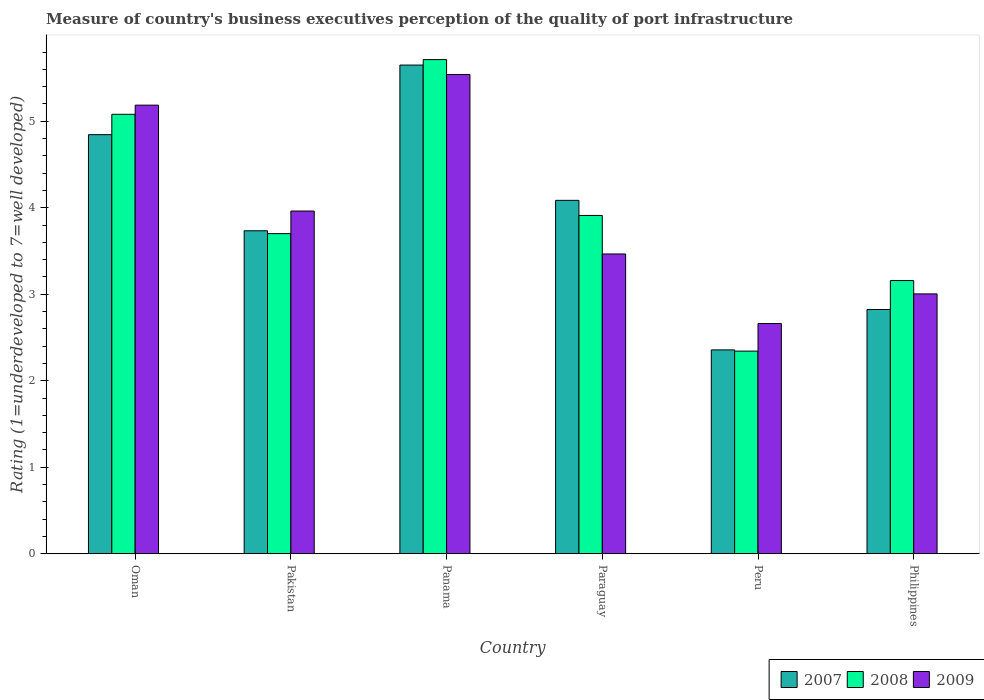How many groups of bars are there?
Ensure brevity in your answer.  6. Are the number of bars per tick equal to the number of legend labels?
Provide a succinct answer. Yes. Are the number of bars on each tick of the X-axis equal?
Provide a short and direct response. Yes. How many bars are there on the 4th tick from the left?
Make the answer very short. 3. How many bars are there on the 1st tick from the right?
Make the answer very short. 3. What is the label of the 1st group of bars from the left?
Offer a terse response. Oman. What is the ratings of the quality of port infrastructure in 2009 in Pakistan?
Give a very brief answer. 3.96. Across all countries, what is the maximum ratings of the quality of port infrastructure in 2007?
Your response must be concise. 5.65. Across all countries, what is the minimum ratings of the quality of port infrastructure in 2007?
Offer a very short reply. 2.36. In which country was the ratings of the quality of port infrastructure in 2009 maximum?
Give a very brief answer. Panama. In which country was the ratings of the quality of port infrastructure in 2009 minimum?
Make the answer very short. Peru. What is the total ratings of the quality of port infrastructure in 2008 in the graph?
Your answer should be compact. 23.91. What is the difference between the ratings of the quality of port infrastructure in 2009 in Oman and that in Pakistan?
Offer a terse response. 1.22. What is the difference between the ratings of the quality of port infrastructure in 2009 in Philippines and the ratings of the quality of port infrastructure in 2007 in Peru?
Give a very brief answer. 0.65. What is the average ratings of the quality of port infrastructure in 2007 per country?
Make the answer very short. 3.92. What is the difference between the ratings of the quality of port infrastructure of/in 2009 and ratings of the quality of port infrastructure of/in 2008 in Paraguay?
Ensure brevity in your answer.  -0.45. What is the ratio of the ratings of the quality of port infrastructure in 2009 in Pakistan to that in Paraguay?
Ensure brevity in your answer.  1.14. Is the ratings of the quality of port infrastructure in 2008 in Panama less than that in Paraguay?
Make the answer very short. No. What is the difference between the highest and the second highest ratings of the quality of port infrastructure in 2009?
Your answer should be very brief. 1.22. What is the difference between the highest and the lowest ratings of the quality of port infrastructure in 2008?
Provide a succinct answer. 3.37. Is the sum of the ratings of the quality of port infrastructure in 2007 in Pakistan and Panama greater than the maximum ratings of the quality of port infrastructure in 2008 across all countries?
Your answer should be compact. Yes. What does the 3rd bar from the right in Paraguay represents?
Make the answer very short. 2007. How many bars are there?
Offer a terse response. 18. How many countries are there in the graph?
Give a very brief answer. 6. What is the difference between two consecutive major ticks on the Y-axis?
Provide a succinct answer. 1. Does the graph contain any zero values?
Offer a terse response. No. Where does the legend appear in the graph?
Your answer should be compact. Bottom right. How many legend labels are there?
Ensure brevity in your answer.  3. How are the legend labels stacked?
Give a very brief answer. Horizontal. What is the title of the graph?
Provide a succinct answer. Measure of country's business executives perception of the quality of port infrastructure. What is the label or title of the Y-axis?
Ensure brevity in your answer.  Rating (1=underdeveloped to 7=well developed). What is the Rating (1=underdeveloped to 7=well developed) of 2007 in Oman?
Ensure brevity in your answer.  4.85. What is the Rating (1=underdeveloped to 7=well developed) in 2008 in Oman?
Make the answer very short. 5.08. What is the Rating (1=underdeveloped to 7=well developed) in 2009 in Oman?
Provide a succinct answer. 5.19. What is the Rating (1=underdeveloped to 7=well developed) of 2007 in Pakistan?
Offer a terse response. 3.73. What is the Rating (1=underdeveloped to 7=well developed) in 2008 in Pakistan?
Ensure brevity in your answer.  3.7. What is the Rating (1=underdeveloped to 7=well developed) in 2009 in Pakistan?
Keep it short and to the point. 3.96. What is the Rating (1=underdeveloped to 7=well developed) of 2007 in Panama?
Your response must be concise. 5.65. What is the Rating (1=underdeveloped to 7=well developed) in 2008 in Panama?
Your response must be concise. 5.71. What is the Rating (1=underdeveloped to 7=well developed) in 2009 in Panama?
Your answer should be compact. 5.54. What is the Rating (1=underdeveloped to 7=well developed) in 2007 in Paraguay?
Your answer should be very brief. 4.09. What is the Rating (1=underdeveloped to 7=well developed) in 2008 in Paraguay?
Give a very brief answer. 3.91. What is the Rating (1=underdeveloped to 7=well developed) in 2009 in Paraguay?
Provide a short and direct response. 3.47. What is the Rating (1=underdeveloped to 7=well developed) in 2007 in Peru?
Provide a short and direct response. 2.36. What is the Rating (1=underdeveloped to 7=well developed) in 2008 in Peru?
Your answer should be compact. 2.34. What is the Rating (1=underdeveloped to 7=well developed) of 2009 in Peru?
Keep it short and to the point. 2.66. What is the Rating (1=underdeveloped to 7=well developed) in 2007 in Philippines?
Your answer should be compact. 2.82. What is the Rating (1=underdeveloped to 7=well developed) in 2008 in Philippines?
Make the answer very short. 3.16. What is the Rating (1=underdeveloped to 7=well developed) of 2009 in Philippines?
Ensure brevity in your answer.  3. Across all countries, what is the maximum Rating (1=underdeveloped to 7=well developed) of 2007?
Offer a terse response. 5.65. Across all countries, what is the maximum Rating (1=underdeveloped to 7=well developed) of 2008?
Offer a terse response. 5.71. Across all countries, what is the maximum Rating (1=underdeveloped to 7=well developed) of 2009?
Your answer should be very brief. 5.54. Across all countries, what is the minimum Rating (1=underdeveloped to 7=well developed) of 2007?
Your answer should be very brief. 2.36. Across all countries, what is the minimum Rating (1=underdeveloped to 7=well developed) of 2008?
Give a very brief answer. 2.34. Across all countries, what is the minimum Rating (1=underdeveloped to 7=well developed) of 2009?
Offer a terse response. 2.66. What is the total Rating (1=underdeveloped to 7=well developed) in 2007 in the graph?
Ensure brevity in your answer.  23.49. What is the total Rating (1=underdeveloped to 7=well developed) of 2008 in the graph?
Keep it short and to the point. 23.91. What is the total Rating (1=underdeveloped to 7=well developed) of 2009 in the graph?
Provide a short and direct response. 23.82. What is the difference between the Rating (1=underdeveloped to 7=well developed) of 2007 in Oman and that in Pakistan?
Your answer should be compact. 1.11. What is the difference between the Rating (1=underdeveloped to 7=well developed) of 2008 in Oman and that in Pakistan?
Give a very brief answer. 1.38. What is the difference between the Rating (1=underdeveloped to 7=well developed) in 2009 in Oman and that in Pakistan?
Ensure brevity in your answer.  1.22. What is the difference between the Rating (1=underdeveloped to 7=well developed) of 2007 in Oman and that in Panama?
Make the answer very short. -0.8. What is the difference between the Rating (1=underdeveloped to 7=well developed) in 2008 in Oman and that in Panama?
Make the answer very short. -0.63. What is the difference between the Rating (1=underdeveloped to 7=well developed) of 2009 in Oman and that in Panama?
Give a very brief answer. -0.35. What is the difference between the Rating (1=underdeveloped to 7=well developed) in 2007 in Oman and that in Paraguay?
Offer a very short reply. 0.76. What is the difference between the Rating (1=underdeveloped to 7=well developed) of 2008 in Oman and that in Paraguay?
Give a very brief answer. 1.17. What is the difference between the Rating (1=underdeveloped to 7=well developed) of 2009 in Oman and that in Paraguay?
Offer a terse response. 1.72. What is the difference between the Rating (1=underdeveloped to 7=well developed) in 2007 in Oman and that in Peru?
Your answer should be compact. 2.49. What is the difference between the Rating (1=underdeveloped to 7=well developed) in 2008 in Oman and that in Peru?
Your response must be concise. 2.74. What is the difference between the Rating (1=underdeveloped to 7=well developed) in 2009 in Oman and that in Peru?
Make the answer very short. 2.53. What is the difference between the Rating (1=underdeveloped to 7=well developed) of 2007 in Oman and that in Philippines?
Provide a succinct answer. 2.02. What is the difference between the Rating (1=underdeveloped to 7=well developed) in 2008 in Oman and that in Philippines?
Make the answer very short. 1.92. What is the difference between the Rating (1=underdeveloped to 7=well developed) of 2009 in Oman and that in Philippines?
Provide a short and direct response. 2.18. What is the difference between the Rating (1=underdeveloped to 7=well developed) of 2007 in Pakistan and that in Panama?
Your response must be concise. -1.92. What is the difference between the Rating (1=underdeveloped to 7=well developed) in 2008 in Pakistan and that in Panama?
Ensure brevity in your answer.  -2.01. What is the difference between the Rating (1=underdeveloped to 7=well developed) in 2009 in Pakistan and that in Panama?
Provide a succinct answer. -1.58. What is the difference between the Rating (1=underdeveloped to 7=well developed) of 2007 in Pakistan and that in Paraguay?
Offer a terse response. -0.35. What is the difference between the Rating (1=underdeveloped to 7=well developed) of 2008 in Pakistan and that in Paraguay?
Your answer should be compact. -0.21. What is the difference between the Rating (1=underdeveloped to 7=well developed) of 2009 in Pakistan and that in Paraguay?
Your answer should be very brief. 0.5. What is the difference between the Rating (1=underdeveloped to 7=well developed) in 2007 in Pakistan and that in Peru?
Keep it short and to the point. 1.38. What is the difference between the Rating (1=underdeveloped to 7=well developed) of 2008 in Pakistan and that in Peru?
Offer a terse response. 1.36. What is the difference between the Rating (1=underdeveloped to 7=well developed) of 2009 in Pakistan and that in Peru?
Provide a succinct answer. 1.3. What is the difference between the Rating (1=underdeveloped to 7=well developed) in 2007 in Pakistan and that in Philippines?
Offer a very short reply. 0.91. What is the difference between the Rating (1=underdeveloped to 7=well developed) in 2008 in Pakistan and that in Philippines?
Offer a terse response. 0.54. What is the difference between the Rating (1=underdeveloped to 7=well developed) in 2009 in Pakistan and that in Philippines?
Your answer should be compact. 0.96. What is the difference between the Rating (1=underdeveloped to 7=well developed) of 2007 in Panama and that in Paraguay?
Offer a very short reply. 1.56. What is the difference between the Rating (1=underdeveloped to 7=well developed) in 2008 in Panama and that in Paraguay?
Give a very brief answer. 1.8. What is the difference between the Rating (1=underdeveloped to 7=well developed) of 2009 in Panama and that in Paraguay?
Make the answer very short. 2.08. What is the difference between the Rating (1=underdeveloped to 7=well developed) in 2007 in Panama and that in Peru?
Offer a terse response. 3.29. What is the difference between the Rating (1=underdeveloped to 7=well developed) of 2008 in Panama and that in Peru?
Your response must be concise. 3.37. What is the difference between the Rating (1=underdeveloped to 7=well developed) in 2009 in Panama and that in Peru?
Give a very brief answer. 2.88. What is the difference between the Rating (1=underdeveloped to 7=well developed) in 2007 in Panama and that in Philippines?
Offer a terse response. 2.83. What is the difference between the Rating (1=underdeveloped to 7=well developed) of 2008 in Panama and that in Philippines?
Make the answer very short. 2.56. What is the difference between the Rating (1=underdeveloped to 7=well developed) of 2009 in Panama and that in Philippines?
Offer a very short reply. 2.54. What is the difference between the Rating (1=underdeveloped to 7=well developed) in 2007 in Paraguay and that in Peru?
Make the answer very short. 1.73. What is the difference between the Rating (1=underdeveloped to 7=well developed) in 2008 in Paraguay and that in Peru?
Give a very brief answer. 1.57. What is the difference between the Rating (1=underdeveloped to 7=well developed) of 2009 in Paraguay and that in Peru?
Provide a short and direct response. 0.8. What is the difference between the Rating (1=underdeveloped to 7=well developed) in 2007 in Paraguay and that in Philippines?
Your response must be concise. 1.26. What is the difference between the Rating (1=underdeveloped to 7=well developed) of 2008 in Paraguay and that in Philippines?
Provide a succinct answer. 0.75. What is the difference between the Rating (1=underdeveloped to 7=well developed) in 2009 in Paraguay and that in Philippines?
Your response must be concise. 0.46. What is the difference between the Rating (1=underdeveloped to 7=well developed) of 2007 in Peru and that in Philippines?
Offer a very short reply. -0.47. What is the difference between the Rating (1=underdeveloped to 7=well developed) in 2008 in Peru and that in Philippines?
Offer a very short reply. -0.82. What is the difference between the Rating (1=underdeveloped to 7=well developed) of 2009 in Peru and that in Philippines?
Keep it short and to the point. -0.34. What is the difference between the Rating (1=underdeveloped to 7=well developed) of 2007 in Oman and the Rating (1=underdeveloped to 7=well developed) of 2008 in Pakistan?
Your answer should be very brief. 1.14. What is the difference between the Rating (1=underdeveloped to 7=well developed) of 2007 in Oman and the Rating (1=underdeveloped to 7=well developed) of 2009 in Pakistan?
Offer a very short reply. 0.88. What is the difference between the Rating (1=underdeveloped to 7=well developed) in 2008 in Oman and the Rating (1=underdeveloped to 7=well developed) in 2009 in Pakistan?
Offer a terse response. 1.12. What is the difference between the Rating (1=underdeveloped to 7=well developed) of 2007 in Oman and the Rating (1=underdeveloped to 7=well developed) of 2008 in Panama?
Your response must be concise. -0.87. What is the difference between the Rating (1=underdeveloped to 7=well developed) in 2007 in Oman and the Rating (1=underdeveloped to 7=well developed) in 2009 in Panama?
Your answer should be compact. -0.7. What is the difference between the Rating (1=underdeveloped to 7=well developed) of 2008 in Oman and the Rating (1=underdeveloped to 7=well developed) of 2009 in Panama?
Keep it short and to the point. -0.46. What is the difference between the Rating (1=underdeveloped to 7=well developed) in 2007 in Oman and the Rating (1=underdeveloped to 7=well developed) in 2008 in Paraguay?
Your answer should be compact. 0.93. What is the difference between the Rating (1=underdeveloped to 7=well developed) in 2007 in Oman and the Rating (1=underdeveloped to 7=well developed) in 2009 in Paraguay?
Your response must be concise. 1.38. What is the difference between the Rating (1=underdeveloped to 7=well developed) in 2008 in Oman and the Rating (1=underdeveloped to 7=well developed) in 2009 in Paraguay?
Provide a short and direct response. 1.62. What is the difference between the Rating (1=underdeveloped to 7=well developed) in 2007 in Oman and the Rating (1=underdeveloped to 7=well developed) in 2008 in Peru?
Ensure brevity in your answer.  2.5. What is the difference between the Rating (1=underdeveloped to 7=well developed) in 2007 in Oman and the Rating (1=underdeveloped to 7=well developed) in 2009 in Peru?
Provide a succinct answer. 2.18. What is the difference between the Rating (1=underdeveloped to 7=well developed) of 2008 in Oman and the Rating (1=underdeveloped to 7=well developed) of 2009 in Peru?
Make the answer very short. 2.42. What is the difference between the Rating (1=underdeveloped to 7=well developed) of 2007 in Oman and the Rating (1=underdeveloped to 7=well developed) of 2008 in Philippines?
Your response must be concise. 1.69. What is the difference between the Rating (1=underdeveloped to 7=well developed) of 2007 in Oman and the Rating (1=underdeveloped to 7=well developed) of 2009 in Philippines?
Give a very brief answer. 1.84. What is the difference between the Rating (1=underdeveloped to 7=well developed) of 2008 in Oman and the Rating (1=underdeveloped to 7=well developed) of 2009 in Philippines?
Ensure brevity in your answer.  2.08. What is the difference between the Rating (1=underdeveloped to 7=well developed) in 2007 in Pakistan and the Rating (1=underdeveloped to 7=well developed) in 2008 in Panama?
Provide a short and direct response. -1.98. What is the difference between the Rating (1=underdeveloped to 7=well developed) of 2007 in Pakistan and the Rating (1=underdeveloped to 7=well developed) of 2009 in Panama?
Provide a succinct answer. -1.81. What is the difference between the Rating (1=underdeveloped to 7=well developed) in 2008 in Pakistan and the Rating (1=underdeveloped to 7=well developed) in 2009 in Panama?
Make the answer very short. -1.84. What is the difference between the Rating (1=underdeveloped to 7=well developed) in 2007 in Pakistan and the Rating (1=underdeveloped to 7=well developed) in 2008 in Paraguay?
Provide a succinct answer. -0.18. What is the difference between the Rating (1=underdeveloped to 7=well developed) in 2007 in Pakistan and the Rating (1=underdeveloped to 7=well developed) in 2009 in Paraguay?
Make the answer very short. 0.27. What is the difference between the Rating (1=underdeveloped to 7=well developed) in 2008 in Pakistan and the Rating (1=underdeveloped to 7=well developed) in 2009 in Paraguay?
Provide a succinct answer. 0.24. What is the difference between the Rating (1=underdeveloped to 7=well developed) of 2007 in Pakistan and the Rating (1=underdeveloped to 7=well developed) of 2008 in Peru?
Your answer should be very brief. 1.39. What is the difference between the Rating (1=underdeveloped to 7=well developed) of 2007 in Pakistan and the Rating (1=underdeveloped to 7=well developed) of 2009 in Peru?
Provide a short and direct response. 1.07. What is the difference between the Rating (1=underdeveloped to 7=well developed) of 2008 in Pakistan and the Rating (1=underdeveloped to 7=well developed) of 2009 in Peru?
Your response must be concise. 1.04. What is the difference between the Rating (1=underdeveloped to 7=well developed) in 2007 in Pakistan and the Rating (1=underdeveloped to 7=well developed) in 2008 in Philippines?
Offer a very short reply. 0.58. What is the difference between the Rating (1=underdeveloped to 7=well developed) of 2007 in Pakistan and the Rating (1=underdeveloped to 7=well developed) of 2009 in Philippines?
Your response must be concise. 0.73. What is the difference between the Rating (1=underdeveloped to 7=well developed) in 2008 in Pakistan and the Rating (1=underdeveloped to 7=well developed) in 2009 in Philippines?
Your response must be concise. 0.7. What is the difference between the Rating (1=underdeveloped to 7=well developed) of 2007 in Panama and the Rating (1=underdeveloped to 7=well developed) of 2008 in Paraguay?
Your answer should be compact. 1.74. What is the difference between the Rating (1=underdeveloped to 7=well developed) in 2007 in Panama and the Rating (1=underdeveloped to 7=well developed) in 2009 in Paraguay?
Give a very brief answer. 2.18. What is the difference between the Rating (1=underdeveloped to 7=well developed) in 2008 in Panama and the Rating (1=underdeveloped to 7=well developed) in 2009 in Paraguay?
Your response must be concise. 2.25. What is the difference between the Rating (1=underdeveloped to 7=well developed) of 2007 in Panama and the Rating (1=underdeveloped to 7=well developed) of 2008 in Peru?
Your response must be concise. 3.31. What is the difference between the Rating (1=underdeveloped to 7=well developed) in 2007 in Panama and the Rating (1=underdeveloped to 7=well developed) in 2009 in Peru?
Give a very brief answer. 2.99. What is the difference between the Rating (1=underdeveloped to 7=well developed) of 2008 in Panama and the Rating (1=underdeveloped to 7=well developed) of 2009 in Peru?
Your answer should be compact. 3.05. What is the difference between the Rating (1=underdeveloped to 7=well developed) of 2007 in Panama and the Rating (1=underdeveloped to 7=well developed) of 2008 in Philippines?
Provide a succinct answer. 2.49. What is the difference between the Rating (1=underdeveloped to 7=well developed) of 2007 in Panama and the Rating (1=underdeveloped to 7=well developed) of 2009 in Philippines?
Keep it short and to the point. 2.65. What is the difference between the Rating (1=underdeveloped to 7=well developed) in 2008 in Panama and the Rating (1=underdeveloped to 7=well developed) in 2009 in Philippines?
Your response must be concise. 2.71. What is the difference between the Rating (1=underdeveloped to 7=well developed) of 2007 in Paraguay and the Rating (1=underdeveloped to 7=well developed) of 2008 in Peru?
Your answer should be compact. 1.74. What is the difference between the Rating (1=underdeveloped to 7=well developed) in 2007 in Paraguay and the Rating (1=underdeveloped to 7=well developed) in 2009 in Peru?
Offer a terse response. 1.42. What is the difference between the Rating (1=underdeveloped to 7=well developed) in 2008 in Paraguay and the Rating (1=underdeveloped to 7=well developed) in 2009 in Peru?
Ensure brevity in your answer.  1.25. What is the difference between the Rating (1=underdeveloped to 7=well developed) of 2007 in Paraguay and the Rating (1=underdeveloped to 7=well developed) of 2008 in Philippines?
Give a very brief answer. 0.93. What is the difference between the Rating (1=underdeveloped to 7=well developed) in 2007 in Paraguay and the Rating (1=underdeveloped to 7=well developed) in 2009 in Philippines?
Keep it short and to the point. 1.08. What is the difference between the Rating (1=underdeveloped to 7=well developed) in 2008 in Paraguay and the Rating (1=underdeveloped to 7=well developed) in 2009 in Philippines?
Ensure brevity in your answer.  0.91. What is the difference between the Rating (1=underdeveloped to 7=well developed) of 2007 in Peru and the Rating (1=underdeveloped to 7=well developed) of 2008 in Philippines?
Make the answer very short. -0.8. What is the difference between the Rating (1=underdeveloped to 7=well developed) of 2007 in Peru and the Rating (1=underdeveloped to 7=well developed) of 2009 in Philippines?
Make the answer very short. -0.65. What is the difference between the Rating (1=underdeveloped to 7=well developed) of 2008 in Peru and the Rating (1=underdeveloped to 7=well developed) of 2009 in Philippines?
Your answer should be very brief. -0.66. What is the average Rating (1=underdeveloped to 7=well developed) in 2007 per country?
Your answer should be very brief. 3.92. What is the average Rating (1=underdeveloped to 7=well developed) in 2008 per country?
Your response must be concise. 3.98. What is the average Rating (1=underdeveloped to 7=well developed) of 2009 per country?
Make the answer very short. 3.97. What is the difference between the Rating (1=underdeveloped to 7=well developed) in 2007 and Rating (1=underdeveloped to 7=well developed) in 2008 in Oman?
Make the answer very short. -0.24. What is the difference between the Rating (1=underdeveloped to 7=well developed) of 2007 and Rating (1=underdeveloped to 7=well developed) of 2009 in Oman?
Your answer should be very brief. -0.34. What is the difference between the Rating (1=underdeveloped to 7=well developed) of 2008 and Rating (1=underdeveloped to 7=well developed) of 2009 in Oman?
Offer a terse response. -0.11. What is the difference between the Rating (1=underdeveloped to 7=well developed) in 2007 and Rating (1=underdeveloped to 7=well developed) in 2008 in Pakistan?
Offer a terse response. 0.03. What is the difference between the Rating (1=underdeveloped to 7=well developed) of 2007 and Rating (1=underdeveloped to 7=well developed) of 2009 in Pakistan?
Your response must be concise. -0.23. What is the difference between the Rating (1=underdeveloped to 7=well developed) of 2008 and Rating (1=underdeveloped to 7=well developed) of 2009 in Pakistan?
Make the answer very short. -0.26. What is the difference between the Rating (1=underdeveloped to 7=well developed) of 2007 and Rating (1=underdeveloped to 7=well developed) of 2008 in Panama?
Provide a short and direct response. -0.06. What is the difference between the Rating (1=underdeveloped to 7=well developed) in 2007 and Rating (1=underdeveloped to 7=well developed) in 2009 in Panama?
Your response must be concise. 0.11. What is the difference between the Rating (1=underdeveloped to 7=well developed) in 2008 and Rating (1=underdeveloped to 7=well developed) in 2009 in Panama?
Your answer should be very brief. 0.17. What is the difference between the Rating (1=underdeveloped to 7=well developed) in 2007 and Rating (1=underdeveloped to 7=well developed) in 2008 in Paraguay?
Your answer should be very brief. 0.17. What is the difference between the Rating (1=underdeveloped to 7=well developed) of 2007 and Rating (1=underdeveloped to 7=well developed) of 2009 in Paraguay?
Offer a terse response. 0.62. What is the difference between the Rating (1=underdeveloped to 7=well developed) in 2008 and Rating (1=underdeveloped to 7=well developed) in 2009 in Paraguay?
Give a very brief answer. 0.45. What is the difference between the Rating (1=underdeveloped to 7=well developed) in 2007 and Rating (1=underdeveloped to 7=well developed) in 2008 in Peru?
Your answer should be compact. 0.01. What is the difference between the Rating (1=underdeveloped to 7=well developed) of 2007 and Rating (1=underdeveloped to 7=well developed) of 2009 in Peru?
Your answer should be compact. -0.3. What is the difference between the Rating (1=underdeveloped to 7=well developed) of 2008 and Rating (1=underdeveloped to 7=well developed) of 2009 in Peru?
Offer a very short reply. -0.32. What is the difference between the Rating (1=underdeveloped to 7=well developed) in 2007 and Rating (1=underdeveloped to 7=well developed) in 2008 in Philippines?
Offer a terse response. -0.33. What is the difference between the Rating (1=underdeveloped to 7=well developed) in 2007 and Rating (1=underdeveloped to 7=well developed) in 2009 in Philippines?
Offer a terse response. -0.18. What is the difference between the Rating (1=underdeveloped to 7=well developed) of 2008 and Rating (1=underdeveloped to 7=well developed) of 2009 in Philippines?
Your answer should be very brief. 0.15. What is the ratio of the Rating (1=underdeveloped to 7=well developed) in 2007 in Oman to that in Pakistan?
Give a very brief answer. 1.3. What is the ratio of the Rating (1=underdeveloped to 7=well developed) in 2008 in Oman to that in Pakistan?
Your answer should be very brief. 1.37. What is the ratio of the Rating (1=underdeveloped to 7=well developed) of 2009 in Oman to that in Pakistan?
Provide a succinct answer. 1.31. What is the ratio of the Rating (1=underdeveloped to 7=well developed) of 2007 in Oman to that in Panama?
Offer a terse response. 0.86. What is the ratio of the Rating (1=underdeveloped to 7=well developed) in 2008 in Oman to that in Panama?
Offer a terse response. 0.89. What is the ratio of the Rating (1=underdeveloped to 7=well developed) in 2009 in Oman to that in Panama?
Offer a very short reply. 0.94. What is the ratio of the Rating (1=underdeveloped to 7=well developed) of 2007 in Oman to that in Paraguay?
Offer a very short reply. 1.19. What is the ratio of the Rating (1=underdeveloped to 7=well developed) in 2008 in Oman to that in Paraguay?
Provide a short and direct response. 1.3. What is the ratio of the Rating (1=underdeveloped to 7=well developed) in 2009 in Oman to that in Paraguay?
Your answer should be very brief. 1.5. What is the ratio of the Rating (1=underdeveloped to 7=well developed) in 2007 in Oman to that in Peru?
Your answer should be compact. 2.06. What is the ratio of the Rating (1=underdeveloped to 7=well developed) of 2008 in Oman to that in Peru?
Your answer should be compact. 2.17. What is the ratio of the Rating (1=underdeveloped to 7=well developed) of 2009 in Oman to that in Peru?
Your response must be concise. 1.95. What is the ratio of the Rating (1=underdeveloped to 7=well developed) of 2007 in Oman to that in Philippines?
Provide a short and direct response. 1.72. What is the ratio of the Rating (1=underdeveloped to 7=well developed) in 2008 in Oman to that in Philippines?
Your answer should be very brief. 1.61. What is the ratio of the Rating (1=underdeveloped to 7=well developed) of 2009 in Oman to that in Philippines?
Make the answer very short. 1.73. What is the ratio of the Rating (1=underdeveloped to 7=well developed) in 2007 in Pakistan to that in Panama?
Ensure brevity in your answer.  0.66. What is the ratio of the Rating (1=underdeveloped to 7=well developed) of 2008 in Pakistan to that in Panama?
Make the answer very short. 0.65. What is the ratio of the Rating (1=underdeveloped to 7=well developed) in 2009 in Pakistan to that in Panama?
Make the answer very short. 0.72. What is the ratio of the Rating (1=underdeveloped to 7=well developed) in 2007 in Pakistan to that in Paraguay?
Provide a short and direct response. 0.91. What is the ratio of the Rating (1=underdeveloped to 7=well developed) of 2008 in Pakistan to that in Paraguay?
Offer a terse response. 0.95. What is the ratio of the Rating (1=underdeveloped to 7=well developed) of 2009 in Pakistan to that in Paraguay?
Offer a very short reply. 1.14. What is the ratio of the Rating (1=underdeveloped to 7=well developed) of 2007 in Pakistan to that in Peru?
Your answer should be very brief. 1.58. What is the ratio of the Rating (1=underdeveloped to 7=well developed) of 2008 in Pakistan to that in Peru?
Provide a succinct answer. 1.58. What is the ratio of the Rating (1=underdeveloped to 7=well developed) in 2009 in Pakistan to that in Peru?
Ensure brevity in your answer.  1.49. What is the ratio of the Rating (1=underdeveloped to 7=well developed) of 2007 in Pakistan to that in Philippines?
Your answer should be compact. 1.32. What is the ratio of the Rating (1=underdeveloped to 7=well developed) of 2008 in Pakistan to that in Philippines?
Offer a very short reply. 1.17. What is the ratio of the Rating (1=underdeveloped to 7=well developed) in 2009 in Pakistan to that in Philippines?
Your answer should be compact. 1.32. What is the ratio of the Rating (1=underdeveloped to 7=well developed) in 2007 in Panama to that in Paraguay?
Make the answer very short. 1.38. What is the ratio of the Rating (1=underdeveloped to 7=well developed) of 2008 in Panama to that in Paraguay?
Your answer should be very brief. 1.46. What is the ratio of the Rating (1=underdeveloped to 7=well developed) of 2009 in Panama to that in Paraguay?
Provide a short and direct response. 1.6. What is the ratio of the Rating (1=underdeveloped to 7=well developed) of 2007 in Panama to that in Peru?
Offer a very short reply. 2.4. What is the ratio of the Rating (1=underdeveloped to 7=well developed) of 2008 in Panama to that in Peru?
Make the answer very short. 2.44. What is the ratio of the Rating (1=underdeveloped to 7=well developed) of 2009 in Panama to that in Peru?
Offer a terse response. 2.08. What is the ratio of the Rating (1=underdeveloped to 7=well developed) of 2007 in Panama to that in Philippines?
Give a very brief answer. 2. What is the ratio of the Rating (1=underdeveloped to 7=well developed) of 2008 in Panama to that in Philippines?
Keep it short and to the point. 1.81. What is the ratio of the Rating (1=underdeveloped to 7=well developed) in 2009 in Panama to that in Philippines?
Offer a very short reply. 1.84. What is the ratio of the Rating (1=underdeveloped to 7=well developed) in 2007 in Paraguay to that in Peru?
Give a very brief answer. 1.73. What is the ratio of the Rating (1=underdeveloped to 7=well developed) in 2008 in Paraguay to that in Peru?
Ensure brevity in your answer.  1.67. What is the ratio of the Rating (1=underdeveloped to 7=well developed) in 2009 in Paraguay to that in Peru?
Your answer should be compact. 1.3. What is the ratio of the Rating (1=underdeveloped to 7=well developed) in 2007 in Paraguay to that in Philippines?
Your answer should be very brief. 1.45. What is the ratio of the Rating (1=underdeveloped to 7=well developed) of 2008 in Paraguay to that in Philippines?
Your answer should be compact. 1.24. What is the ratio of the Rating (1=underdeveloped to 7=well developed) of 2009 in Paraguay to that in Philippines?
Offer a terse response. 1.15. What is the ratio of the Rating (1=underdeveloped to 7=well developed) in 2007 in Peru to that in Philippines?
Make the answer very short. 0.83. What is the ratio of the Rating (1=underdeveloped to 7=well developed) in 2008 in Peru to that in Philippines?
Provide a succinct answer. 0.74. What is the ratio of the Rating (1=underdeveloped to 7=well developed) of 2009 in Peru to that in Philippines?
Keep it short and to the point. 0.89. What is the difference between the highest and the second highest Rating (1=underdeveloped to 7=well developed) in 2007?
Provide a succinct answer. 0.8. What is the difference between the highest and the second highest Rating (1=underdeveloped to 7=well developed) in 2008?
Keep it short and to the point. 0.63. What is the difference between the highest and the second highest Rating (1=underdeveloped to 7=well developed) of 2009?
Make the answer very short. 0.35. What is the difference between the highest and the lowest Rating (1=underdeveloped to 7=well developed) of 2007?
Make the answer very short. 3.29. What is the difference between the highest and the lowest Rating (1=underdeveloped to 7=well developed) of 2008?
Ensure brevity in your answer.  3.37. What is the difference between the highest and the lowest Rating (1=underdeveloped to 7=well developed) of 2009?
Ensure brevity in your answer.  2.88. 